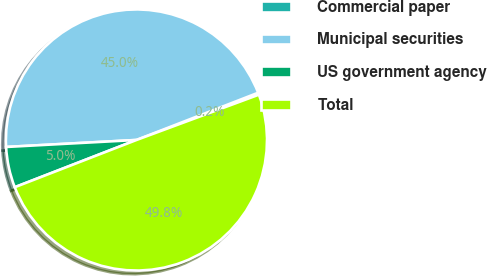Convert chart to OTSL. <chart><loc_0><loc_0><loc_500><loc_500><pie_chart><fcel>Commercial paper<fcel>Municipal securities<fcel>US government agency<fcel>Total<nl><fcel>0.25%<fcel>44.96%<fcel>5.04%<fcel>49.75%<nl></chart> 